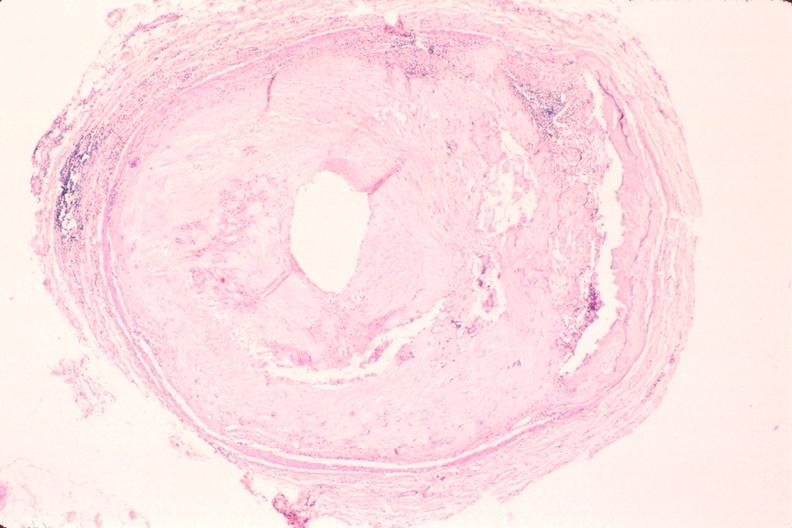does beckwith-wiedemann syndrome show atherosclerosis, right coronary artery?
Answer the question using a single word or phrase. No 